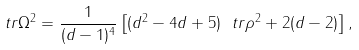Convert formula to latex. <formula><loc_0><loc_0><loc_500><loc_500>\ t r \Omega ^ { 2 } = \frac { 1 } { ( d - 1 ) ^ { 4 } } \left [ ( d ^ { 2 } - 4 d + 5 ) \ t r \rho ^ { 2 } + 2 ( d - 2 ) \right ] ,</formula> 